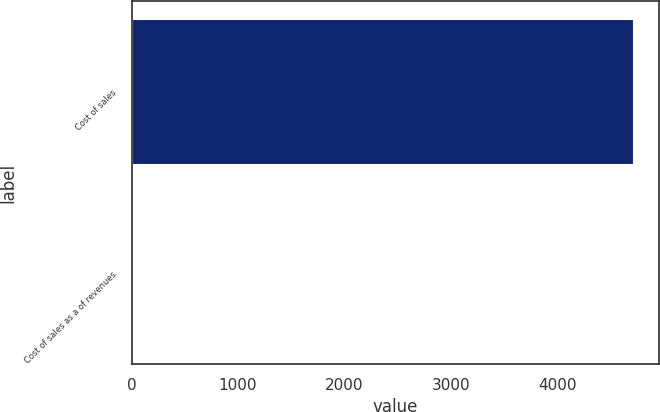<chart> <loc_0><loc_0><loc_500><loc_500><bar_chart><fcel>Cost of sales<fcel>Cost of sales as a of revenues<nl><fcel>4724<fcel>4<nl></chart> 